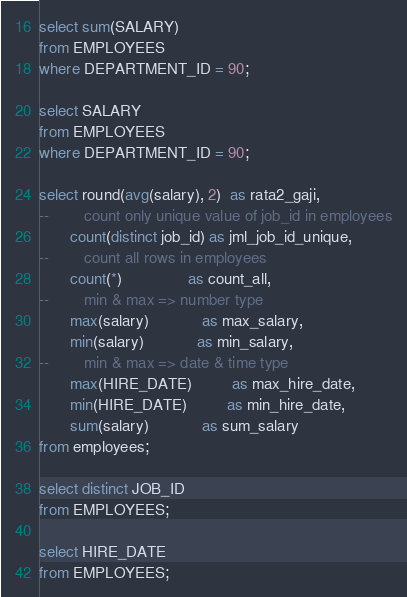<code> <loc_0><loc_0><loc_500><loc_500><_SQL_>select sum(SALARY)
from EMPLOYEES
where DEPARTMENT_ID = 90;

select SALARY
from EMPLOYEES
where DEPARTMENT_ID = 90;

select round(avg(salary), 2)  as rata2_gaji,
--        count only unique value of job_id in employees
       count(distinct job_id) as jml_job_id_unique,
--        count all rows in employees
       count(*)               as count_all,
--        min & max => number type
       max(salary)            as max_salary,
       min(salary)            as min_salary,
--        min & max => date & time type
       max(HIRE_DATE)         as max_hire_date,
       min(HIRE_DATE)         as min_hire_date,
       sum(salary)            as sum_salary
from employees;

select distinct JOB_ID
from EMPLOYEES;

select HIRE_DATE
from EMPLOYEES;
</code> 